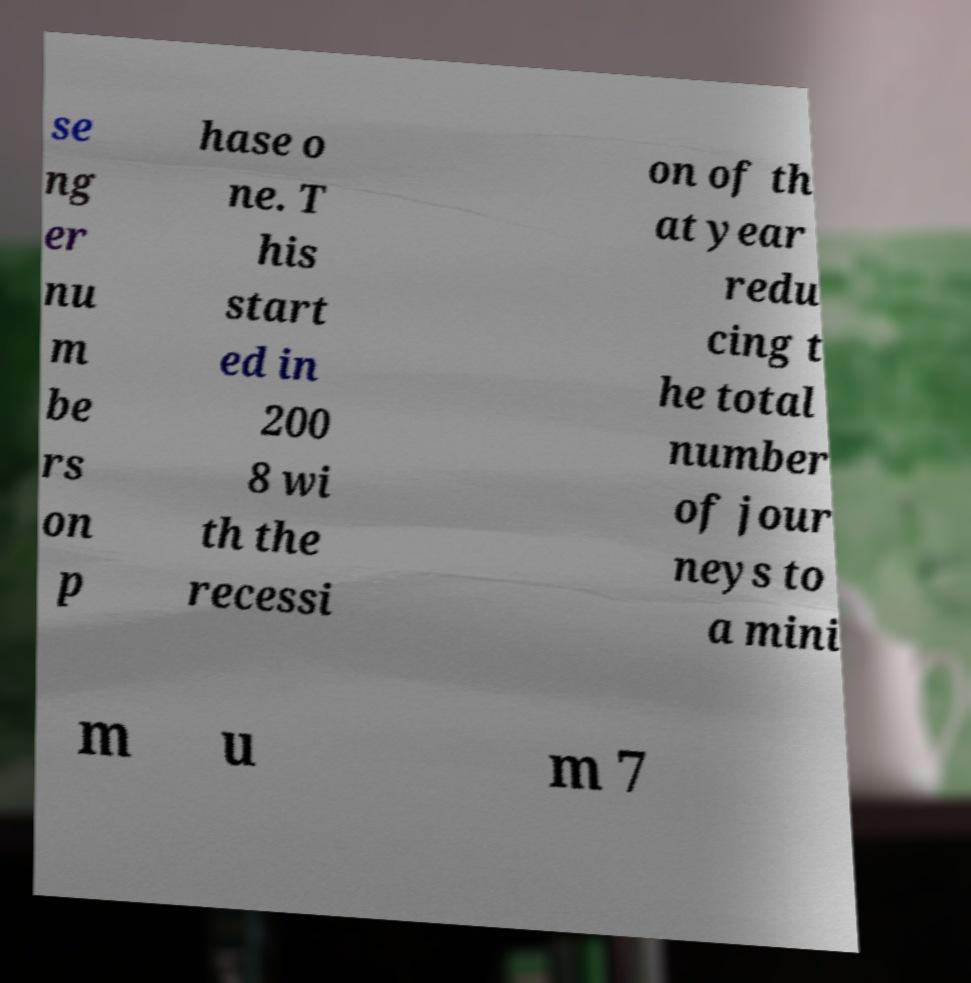Could you extract and type out the text from this image? se ng er nu m be rs on p hase o ne. T his start ed in 200 8 wi th the recessi on of th at year redu cing t he total number of jour neys to a mini m u m 7 